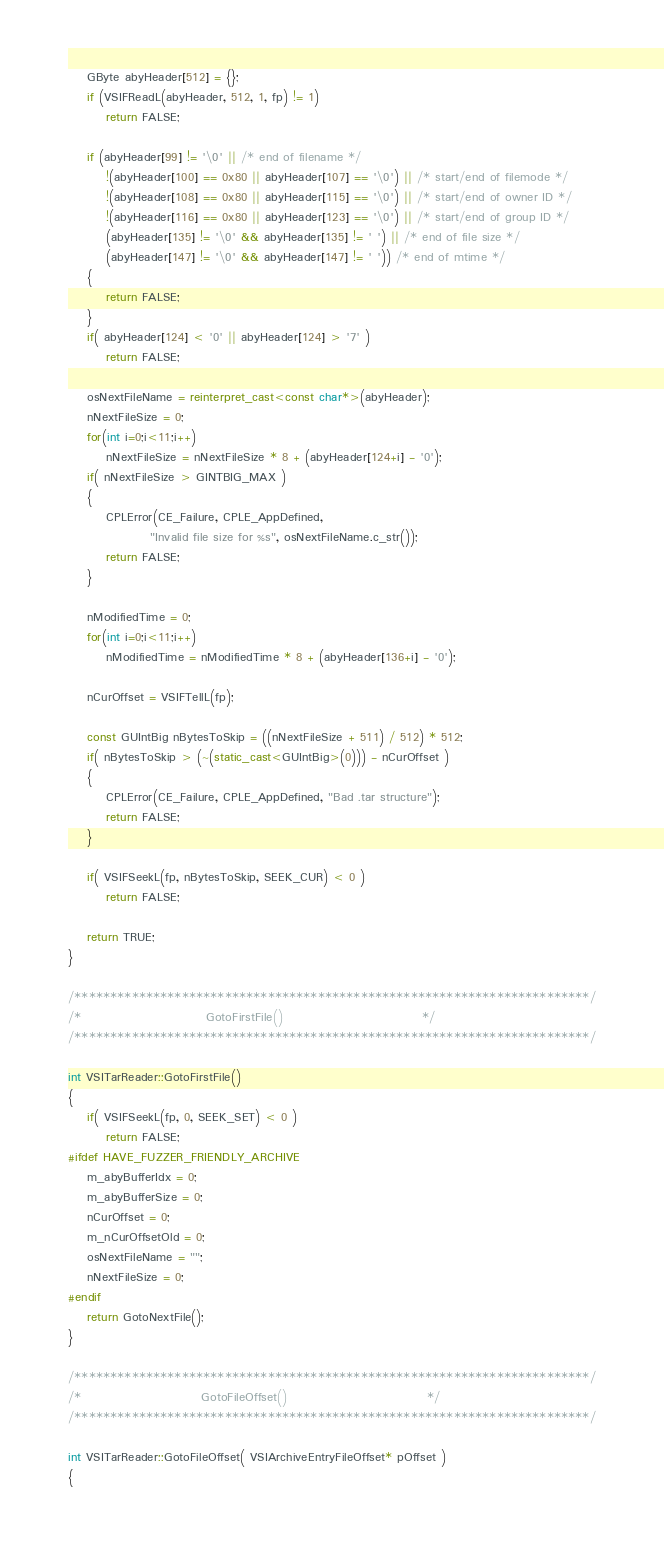Convert code to text. <code><loc_0><loc_0><loc_500><loc_500><_C++_>    GByte abyHeader[512] = {};
    if (VSIFReadL(abyHeader, 512, 1, fp) != 1)
        return FALSE;

    if (abyHeader[99] != '\0' || /* end of filename */
        !(abyHeader[100] == 0x80 || abyHeader[107] == '\0') || /* start/end of filemode */
        !(abyHeader[108] == 0x80 || abyHeader[115] == '\0') || /* start/end of owner ID */
        !(abyHeader[116] == 0x80 || abyHeader[123] == '\0') || /* start/end of group ID */
        (abyHeader[135] != '\0' && abyHeader[135] != ' ') || /* end of file size */
        (abyHeader[147] != '\0' && abyHeader[147] != ' ')) /* end of mtime */
    {
        return FALSE;
    }
    if( abyHeader[124] < '0' || abyHeader[124] > '7' )
        return FALSE;

    osNextFileName = reinterpret_cast<const char*>(abyHeader);
    nNextFileSize = 0;
    for(int i=0;i<11;i++)
        nNextFileSize = nNextFileSize * 8 + (abyHeader[124+i] - '0');
    if( nNextFileSize > GINTBIG_MAX )
    {
        CPLError(CE_Failure, CPLE_AppDefined,
                 "Invalid file size for %s", osNextFileName.c_str());
        return FALSE;
    }

    nModifiedTime = 0;
    for(int i=0;i<11;i++)
        nModifiedTime = nModifiedTime * 8 + (abyHeader[136+i] - '0');

    nCurOffset = VSIFTellL(fp);

    const GUIntBig nBytesToSkip = ((nNextFileSize + 511) / 512) * 512;
    if( nBytesToSkip > (~(static_cast<GUIntBig>(0))) - nCurOffset )
    {
        CPLError(CE_Failure, CPLE_AppDefined, "Bad .tar structure");
        return FALSE;
    }

    if( VSIFSeekL(fp, nBytesToSkip, SEEK_CUR) < 0 )
        return FALSE;

    return TRUE;
}

/************************************************************************/
/*                          GotoFirstFile()                             */
/************************************************************************/

int VSITarReader::GotoFirstFile()
{
    if( VSIFSeekL(fp, 0, SEEK_SET) < 0 )
        return FALSE;
#ifdef HAVE_FUZZER_FRIENDLY_ARCHIVE
    m_abyBufferIdx = 0;
    m_abyBufferSize = 0;
    nCurOffset = 0;
    m_nCurOffsetOld = 0;
    osNextFileName = "";
    nNextFileSize = 0;
#endif
    return GotoNextFile();
}

/************************************************************************/
/*                         GotoFileOffset()                             */
/************************************************************************/

int VSITarReader::GotoFileOffset( VSIArchiveEntryFileOffset* pOffset )
{</code> 